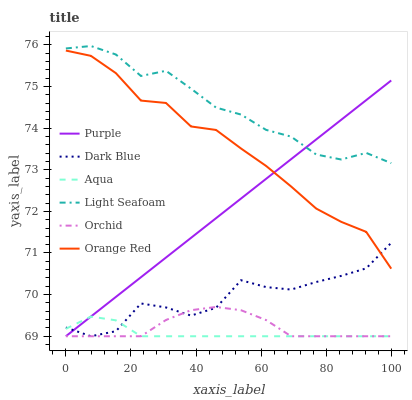Does Aqua have the minimum area under the curve?
Answer yes or no. Yes. Does Light Seafoam have the maximum area under the curve?
Answer yes or no. Yes. Does Dark Blue have the minimum area under the curve?
Answer yes or no. No. Does Dark Blue have the maximum area under the curve?
Answer yes or no. No. Is Purple the smoothest?
Answer yes or no. Yes. Is Dark Blue the roughest?
Answer yes or no. Yes. Is Aqua the smoothest?
Answer yes or no. No. Is Aqua the roughest?
Answer yes or no. No. Does Purple have the lowest value?
Answer yes or no. Yes. Does Light Seafoam have the lowest value?
Answer yes or no. No. Does Light Seafoam have the highest value?
Answer yes or no. Yes. Does Dark Blue have the highest value?
Answer yes or no. No. Is Orange Red less than Light Seafoam?
Answer yes or no. Yes. Is Light Seafoam greater than Dark Blue?
Answer yes or no. Yes. Does Aqua intersect Dark Blue?
Answer yes or no. Yes. Is Aqua less than Dark Blue?
Answer yes or no. No. Is Aqua greater than Dark Blue?
Answer yes or no. No. Does Orange Red intersect Light Seafoam?
Answer yes or no. No. 